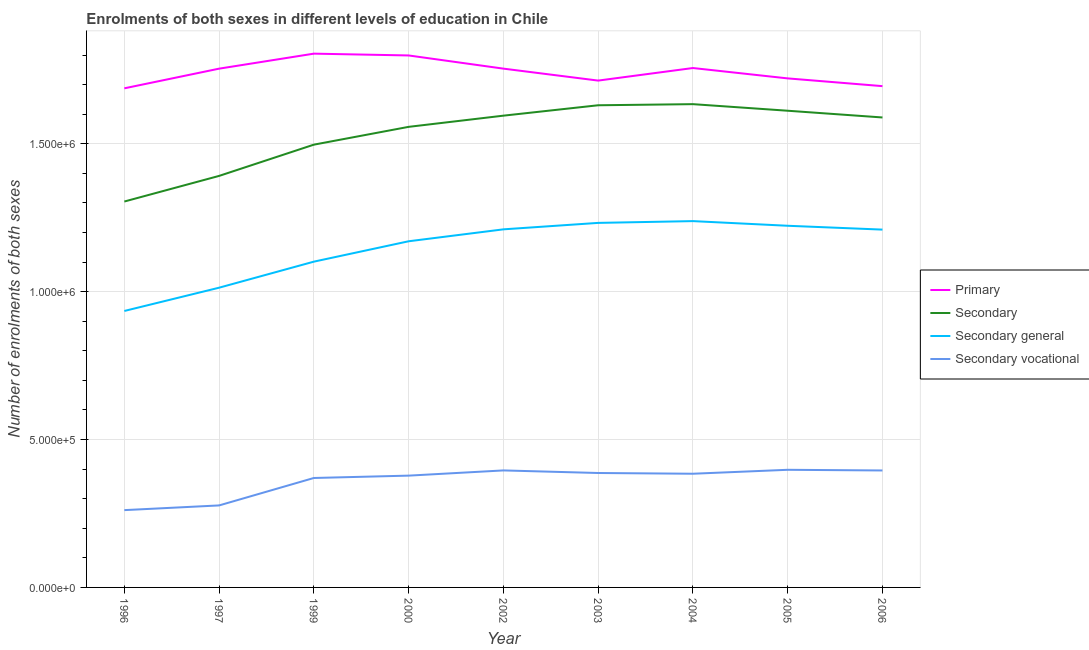Does the line corresponding to number of enrolments in secondary general education intersect with the line corresponding to number of enrolments in primary education?
Your answer should be compact. No. Is the number of lines equal to the number of legend labels?
Your answer should be very brief. Yes. What is the number of enrolments in secondary vocational education in 2004?
Your answer should be very brief. 3.84e+05. Across all years, what is the maximum number of enrolments in primary education?
Ensure brevity in your answer.  1.80e+06. Across all years, what is the minimum number of enrolments in secondary general education?
Offer a terse response. 9.35e+05. What is the total number of enrolments in secondary vocational education in the graph?
Give a very brief answer. 3.25e+06. What is the difference between the number of enrolments in secondary general education in 2002 and that in 2004?
Give a very brief answer. -2.78e+04. What is the difference between the number of enrolments in primary education in 2002 and the number of enrolments in secondary general education in 2000?
Your answer should be very brief. 5.84e+05. What is the average number of enrolments in secondary vocational education per year?
Provide a succinct answer. 3.61e+05. In the year 1996, what is the difference between the number of enrolments in secondary vocational education and number of enrolments in secondary general education?
Offer a very short reply. -6.73e+05. In how many years, is the number of enrolments in secondary general education greater than 500000?
Give a very brief answer. 9. What is the ratio of the number of enrolments in secondary education in 2000 to that in 2004?
Your answer should be very brief. 0.95. Is the number of enrolments in secondary vocational education in 1997 less than that in 2003?
Provide a short and direct response. Yes. What is the difference between the highest and the second highest number of enrolments in secondary vocational education?
Give a very brief answer. 2116. What is the difference between the highest and the lowest number of enrolments in secondary general education?
Your response must be concise. 3.04e+05. Is the sum of the number of enrolments in primary education in 1997 and 2005 greater than the maximum number of enrolments in secondary general education across all years?
Your response must be concise. Yes. Is it the case that in every year, the sum of the number of enrolments in secondary education and number of enrolments in primary education is greater than the sum of number of enrolments in secondary general education and number of enrolments in secondary vocational education?
Your answer should be compact. No. Does the number of enrolments in primary education monotonically increase over the years?
Keep it short and to the point. No. How many years are there in the graph?
Your response must be concise. 9. What is the difference between two consecutive major ticks on the Y-axis?
Give a very brief answer. 5.00e+05. Are the values on the major ticks of Y-axis written in scientific E-notation?
Make the answer very short. Yes. How many legend labels are there?
Provide a short and direct response. 4. How are the legend labels stacked?
Keep it short and to the point. Vertical. What is the title of the graph?
Give a very brief answer. Enrolments of both sexes in different levels of education in Chile. Does "Japan" appear as one of the legend labels in the graph?
Give a very brief answer. No. What is the label or title of the X-axis?
Ensure brevity in your answer.  Year. What is the label or title of the Y-axis?
Provide a short and direct response. Number of enrolments of both sexes. What is the Number of enrolments of both sexes of Primary in 1996?
Provide a short and direct response. 1.69e+06. What is the Number of enrolments of both sexes in Secondary in 1996?
Your answer should be compact. 1.30e+06. What is the Number of enrolments of both sexes in Secondary general in 1996?
Provide a succinct answer. 9.35e+05. What is the Number of enrolments of both sexes of Secondary vocational in 1996?
Your answer should be compact. 2.61e+05. What is the Number of enrolments of both sexes of Primary in 1997?
Provide a short and direct response. 1.75e+06. What is the Number of enrolments of both sexes of Secondary in 1997?
Your response must be concise. 1.39e+06. What is the Number of enrolments of both sexes in Secondary general in 1997?
Your answer should be very brief. 1.01e+06. What is the Number of enrolments of both sexes in Secondary vocational in 1997?
Keep it short and to the point. 2.77e+05. What is the Number of enrolments of both sexes in Primary in 1999?
Ensure brevity in your answer.  1.80e+06. What is the Number of enrolments of both sexes of Secondary in 1999?
Ensure brevity in your answer.  1.50e+06. What is the Number of enrolments of both sexes in Secondary general in 1999?
Make the answer very short. 1.10e+06. What is the Number of enrolments of both sexes of Secondary vocational in 1999?
Keep it short and to the point. 3.70e+05. What is the Number of enrolments of both sexes in Primary in 2000?
Ensure brevity in your answer.  1.80e+06. What is the Number of enrolments of both sexes of Secondary in 2000?
Give a very brief answer. 1.56e+06. What is the Number of enrolments of both sexes in Secondary general in 2000?
Provide a short and direct response. 1.17e+06. What is the Number of enrolments of both sexes of Secondary vocational in 2000?
Give a very brief answer. 3.78e+05. What is the Number of enrolments of both sexes in Primary in 2002?
Ensure brevity in your answer.  1.75e+06. What is the Number of enrolments of both sexes in Secondary in 2002?
Give a very brief answer. 1.59e+06. What is the Number of enrolments of both sexes of Secondary general in 2002?
Provide a short and direct response. 1.21e+06. What is the Number of enrolments of both sexes of Secondary vocational in 2002?
Make the answer very short. 3.96e+05. What is the Number of enrolments of both sexes of Primary in 2003?
Your answer should be compact. 1.71e+06. What is the Number of enrolments of both sexes of Secondary in 2003?
Ensure brevity in your answer.  1.63e+06. What is the Number of enrolments of both sexes in Secondary general in 2003?
Make the answer very short. 1.23e+06. What is the Number of enrolments of both sexes in Secondary vocational in 2003?
Provide a succinct answer. 3.87e+05. What is the Number of enrolments of both sexes in Primary in 2004?
Offer a very short reply. 1.76e+06. What is the Number of enrolments of both sexes in Secondary in 2004?
Offer a very short reply. 1.63e+06. What is the Number of enrolments of both sexes in Secondary general in 2004?
Ensure brevity in your answer.  1.24e+06. What is the Number of enrolments of both sexes of Secondary vocational in 2004?
Offer a very short reply. 3.84e+05. What is the Number of enrolments of both sexes in Primary in 2005?
Provide a short and direct response. 1.72e+06. What is the Number of enrolments of both sexes in Secondary in 2005?
Give a very brief answer. 1.61e+06. What is the Number of enrolments of both sexes of Secondary general in 2005?
Your response must be concise. 1.22e+06. What is the Number of enrolments of both sexes of Secondary vocational in 2005?
Your answer should be compact. 3.98e+05. What is the Number of enrolments of both sexes in Primary in 2006?
Offer a terse response. 1.69e+06. What is the Number of enrolments of both sexes in Secondary in 2006?
Offer a terse response. 1.59e+06. What is the Number of enrolments of both sexes of Secondary general in 2006?
Make the answer very short. 1.21e+06. What is the Number of enrolments of both sexes of Secondary vocational in 2006?
Offer a very short reply. 3.95e+05. Across all years, what is the maximum Number of enrolments of both sexes in Primary?
Give a very brief answer. 1.80e+06. Across all years, what is the maximum Number of enrolments of both sexes in Secondary?
Your answer should be compact. 1.63e+06. Across all years, what is the maximum Number of enrolments of both sexes of Secondary general?
Provide a succinct answer. 1.24e+06. Across all years, what is the maximum Number of enrolments of both sexes in Secondary vocational?
Ensure brevity in your answer.  3.98e+05. Across all years, what is the minimum Number of enrolments of both sexes of Primary?
Your answer should be very brief. 1.69e+06. Across all years, what is the minimum Number of enrolments of both sexes of Secondary?
Keep it short and to the point. 1.30e+06. Across all years, what is the minimum Number of enrolments of both sexes of Secondary general?
Ensure brevity in your answer.  9.35e+05. Across all years, what is the minimum Number of enrolments of both sexes of Secondary vocational?
Your response must be concise. 2.61e+05. What is the total Number of enrolments of both sexes of Primary in the graph?
Ensure brevity in your answer.  1.57e+07. What is the total Number of enrolments of both sexes of Secondary in the graph?
Your answer should be compact. 1.38e+07. What is the total Number of enrolments of both sexes of Secondary general in the graph?
Make the answer very short. 1.03e+07. What is the total Number of enrolments of both sexes in Secondary vocational in the graph?
Offer a terse response. 3.25e+06. What is the difference between the Number of enrolments of both sexes in Primary in 1996 and that in 1997?
Offer a terse response. -6.65e+04. What is the difference between the Number of enrolments of both sexes in Secondary in 1996 and that in 1997?
Give a very brief answer. -8.66e+04. What is the difference between the Number of enrolments of both sexes in Secondary general in 1996 and that in 1997?
Your answer should be compact. -7.87e+04. What is the difference between the Number of enrolments of both sexes of Secondary vocational in 1996 and that in 1997?
Ensure brevity in your answer.  -1.59e+04. What is the difference between the Number of enrolments of both sexes of Primary in 1996 and that in 1999?
Make the answer very short. -1.17e+05. What is the difference between the Number of enrolments of both sexes of Secondary in 1996 and that in 1999?
Your answer should be compact. -1.92e+05. What is the difference between the Number of enrolments of both sexes in Secondary general in 1996 and that in 1999?
Your answer should be compact. -1.67e+05. What is the difference between the Number of enrolments of both sexes of Secondary vocational in 1996 and that in 1999?
Provide a succinct answer. -1.09e+05. What is the difference between the Number of enrolments of both sexes of Primary in 1996 and that in 2000?
Ensure brevity in your answer.  -1.11e+05. What is the difference between the Number of enrolments of both sexes of Secondary in 1996 and that in 2000?
Offer a terse response. -2.52e+05. What is the difference between the Number of enrolments of both sexes in Secondary general in 1996 and that in 2000?
Offer a terse response. -2.36e+05. What is the difference between the Number of enrolments of both sexes of Secondary vocational in 1996 and that in 2000?
Provide a short and direct response. -1.17e+05. What is the difference between the Number of enrolments of both sexes of Primary in 1996 and that in 2002?
Provide a short and direct response. -6.66e+04. What is the difference between the Number of enrolments of both sexes in Secondary in 1996 and that in 2002?
Your answer should be compact. -2.90e+05. What is the difference between the Number of enrolments of both sexes in Secondary general in 1996 and that in 2002?
Ensure brevity in your answer.  -2.76e+05. What is the difference between the Number of enrolments of both sexes of Secondary vocational in 1996 and that in 2002?
Give a very brief answer. -1.34e+05. What is the difference between the Number of enrolments of both sexes of Primary in 1996 and that in 2003?
Your response must be concise. -2.62e+04. What is the difference between the Number of enrolments of both sexes of Secondary in 1996 and that in 2003?
Your answer should be very brief. -3.25e+05. What is the difference between the Number of enrolments of both sexes of Secondary general in 1996 and that in 2003?
Your response must be concise. -2.98e+05. What is the difference between the Number of enrolments of both sexes in Secondary vocational in 1996 and that in 2003?
Offer a very short reply. -1.25e+05. What is the difference between the Number of enrolments of both sexes of Primary in 1996 and that in 2004?
Offer a very short reply. -6.86e+04. What is the difference between the Number of enrolments of both sexes of Secondary in 1996 and that in 2004?
Keep it short and to the point. -3.29e+05. What is the difference between the Number of enrolments of both sexes of Secondary general in 1996 and that in 2004?
Your response must be concise. -3.04e+05. What is the difference between the Number of enrolments of both sexes in Secondary vocational in 1996 and that in 2004?
Provide a short and direct response. -1.23e+05. What is the difference between the Number of enrolments of both sexes of Primary in 1996 and that in 2005?
Your response must be concise. -3.36e+04. What is the difference between the Number of enrolments of both sexes of Secondary in 1996 and that in 2005?
Provide a short and direct response. -3.07e+05. What is the difference between the Number of enrolments of both sexes of Secondary general in 1996 and that in 2005?
Provide a short and direct response. -2.88e+05. What is the difference between the Number of enrolments of both sexes in Secondary vocational in 1996 and that in 2005?
Your response must be concise. -1.36e+05. What is the difference between the Number of enrolments of both sexes of Primary in 1996 and that in 2006?
Ensure brevity in your answer.  -7379. What is the difference between the Number of enrolments of both sexes of Secondary in 1996 and that in 2006?
Keep it short and to the point. -2.84e+05. What is the difference between the Number of enrolments of both sexes in Secondary general in 1996 and that in 2006?
Offer a very short reply. -2.75e+05. What is the difference between the Number of enrolments of both sexes of Secondary vocational in 1996 and that in 2006?
Offer a very short reply. -1.34e+05. What is the difference between the Number of enrolments of both sexes of Primary in 1997 and that in 1999?
Your response must be concise. -5.07e+04. What is the difference between the Number of enrolments of both sexes in Secondary in 1997 and that in 1999?
Give a very brief answer. -1.06e+05. What is the difference between the Number of enrolments of both sexes of Secondary general in 1997 and that in 1999?
Give a very brief answer. -8.81e+04. What is the difference between the Number of enrolments of both sexes of Secondary vocational in 1997 and that in 1999?
Your answer should be very brief. -9.28e+04. What is the difference between the Number of enrolments of both sexes in Primary in 1997 and that in 2000?
Your answer should be very brief. -4.46e+04. What is the difference between the Number of enrolments of both sexes of Secondary in 1997 and that in 2000?
Your response must be concise. -1.66e+05. What is the difference between the Number of enrolments of both sexes in Secondary general in 1997 and that in 2000?
Offer a terse response. -1.57e+05. What is the difference between the Number of enrolments of both sexes in Secondary vocational in 1997 and that in 2000?
Your answer should be very brief. -1.01e+05. What is the difference between the Number of enrolments of both sexes of Primary in 1997 and that in 2002?
Make the answer very short. -85. What is the difference between the Number of enrolments of both sexes in Secondary in 1997 and that in 2002?
Give a very brief answer. -2.04e+05. What is the difference between the Number of enrolments of both sexes of Secondary general in 1997 and that in 2002?
Your answer should be very brief. -1.97e+05. What is the difference between the Number of enrolments of both sexes in Secondary vocational in 1997 and that in 2002?
Make the answer very short. -1.18e+05. What is the difference between the Number of enrolments of both sexes of Primary in 1997 and that in 2003?
Give a very brief answer. 4.03e+04. What is the difference between the Number of enrolments of both sexes in Secondary in 1997 and that in 2003?
Give a very brief answer. -2.39e+05. What is the difference between the Number of enrolments of both sexes in Secondary general in 1997 and that in 2003?
Your response must be concise. -2.19e+05. What is the difference between the Number of enrolments of both sexes of Secondary vocational in 1997 and that in 2003?
Give a very brief answer. -1.10e+05. What is the difference between the Number of enrolments of both sexes in Primary in 1997 and that in 2004?
Provide a short and direct response. -2130. What is the difference between the Number of enrolments of both sexes in Secondary in 1997 and that in 2004?
Provide a short and direct response. -2.43e+05. What is the difference between the Number of enrolments of both sexes in Secondary general in 1997 and that in 2004?
Keep it short and to the point. -2.25e+05. What is the difference between the Number of enrolments of both sexes of Secondary vocational in 1997 and that in 2004?
Keep it short and to the point. -1.07e+05. What is the difference between the Number of enrolments of both sexes in Primary in 1997 and that in 2005?
Keep it short and to the point. 3.29e+04. What is the difference between the Number of enrolments of both sexes in Secondary in 1997 and that in 2005?
Ensure brevity in your answer.  -2.20e+05. What is the difference between the Number of enrolments of both sexes in Secondary general in 1997 and that in 2005?
Provide a short and direct response. -2.09e+05. What is the difference between the Number of enrolments of both sexes in Secondary vocational in 1997 and that in 2005?
Provide a short and direct response. -1.20e+05. What is the difference between the Number of enrolments of both sexes in Primary in 1997 and that in 2006?
Give a very brief answer. 5.91e+04. What is the difference between the Number of enrolments of both sexes of Secondary in 1997 and that in 2006?
Offer a very short reply. -1.98e+05. What is the difference between the Number of enrolments of both sexes in Secondary general in 1997 and that in 2006?
Provide a succinct answer. -1.96e+05. What is the difference between the Number of enrolments of both sexes of Secondary vocational in 1997 and that in 2006?
Your response must be concise. -1.18e+05. What is the difference between the Number of enrolments of both sexes of Primary in 1999 and that in 2000?
Ensure brevity in your answer.  6097. What is the difference between the Number of enrolments of both sexes of Secondary in 1999 and that in 2000?
Provide a short and direct response. -6.02e+04. What is the difference between the Number of enrolments of both sexes in Secondary general in 1999 and that in 2000?
Make the answer very short. -6.89e+04. What is the difference between the Number of enrolments of both sexes in Secondary vocational in 1999 and that in 2000?
Your answer should be very brief. -7942. What is the difference between the Number of enrolments of both sexes of Primary in 1999 and that in 2002?
Offer a terse response. 5.07e+04. What is the difference between the Number of enrolments of both sexes in Secondary in 1999 and that in 2002?
Give a very brief answer. -9.80e+04. What is the difference between the Number of enrolments of both sexes in Secondary general in 1999 and that in 2002?
Your answer should be very brief. -1.09e+05. What is the difference between the Number of enrolments of both sexes in Secondary vocational in 1999 and that in 2002?
Your answer should be compact. -2.55e+04. What is the difference between the Number of enrolments of both sexes in Primary in 1999 and that in 2003?
Your response must be concise. 9.11e+04. What is the difference between the Number of enrolments of both sexes in Secondary in 1999 and that in 2003?
Offer a terse response. -1.33e+05. What is the difference between the Number of enrolments of both sexes in Secondary general in 1999 and that in 2003?
Provide a short and direct response. -1.31e+05. What is the difference between the Number of enrolments of both sexes in Secondary vocational in 1999 and that in 2003?
Provide a short and direct response. -1.68e+04. What is the difference between the Number of enrolments of both sexes of Primary in 1999 and that in 2004?
Your answer should be compact. 4.86e+04. What is the difference between the Number of enrolments of both sexes of Secondary in 1999 and that in 2004?
Your answer should be very brief. -1.37e+05. What is the difference between the Number of enrolments of both sexes of Secondary general in 1999 and that in 2004?
Keep it short and to the point. -1.37e+05. What is the difference between the Number of enrolments of both sexes in Secondary vocational in 1999 and that in 2004?
Your answer should be very brief. -1.43e+04. What is the difference between the Number of enrolments of both sexes of Primary in 1999 and that in 2005?
Provide a short and direct response. 8.37e+04. What is the difference between the Number of enrolments of both sexes of Secondary in 1999 and that in 2005?
Offer a terse response. -1.15e+05. What is the difference between the Number of enrolments of both sexes in Secondary general in 1999 and that in 2005?
Your answer should be very brief. -1.21e+05. What is the difference between the Number of enrolments of both sexes in Secondary vocational in 1999 and that in 2005?
Provide a short and direct response. -2.77e+04. What is the difference between the Number of enrolments of both sexes of Primary in 1999 and that in 2006?
Your answer should be very brief. 1.10e+05. What is the difference between the Number of enrolments of both sexes of Secondary in 1999 and that in 2006?
Offer a very short reply. -9.19e+04. What is the difference between the Number of enrolments of both sexes in Secondary general in 1999 and that in 2006?
Make the answer very short. -1.08e+05. What is the difference between the Number of enrolments of both sexes in Secondary vocational in 1999 and that in 2006?
Your response must be concise. -2.54e+04. What is the difference between the Number of enrolments of both sexes in Primary in 2000 and that in 2002?
Provide a short and direct response. 4.46e+04. What is the difference between the Number of enrolments of both sexes of Secondary in 2000 and that in 2002?
Make the answer very short. -3.78e+04. What is the difference between the Number of enrolments of both sexes of Secondary general in 2000 and that in 2002?
Give a very brief answer. -4.03e+04. What is the difference between the Number of enrolments of both sexes of Secondary vocational in 2000 and that in 2002?
Provide a succinct answer. -1.76e+04. What is the difference between the Number of enrolments of both sexes in Primary in 2000 and that in 2003?
Give a very brief answer. 8.50e+04. What is the difference between the Number of enrolments of both sexes of Secondary in 2000 and that in 2003?
Offer a terse response. -7.30e+04. What is the difference between the Number of enrolments of both sexes in Secondary general in 2000 and that in 2003?
Offer a terse response. -6.21e+04. What is the difference between the Number of enrolments of both sexes in Secondary vocational in 2000 and that in 2003?
Ensure brevity in your answer.  -8874. What is the difference between the Number of enrolments of both sexes in Primary in 2000 and that in 2004?
Make the answer very short. 4.25e+04. What is the difference between the Number of enrolments of both sexes of Secondary in 2000 and that in 2004?
Provide a short and direct response. -7.67e+04. What is the difference between the Number of enrolments of both sexes of Secondary general in 2000 and that in 2004?
Ensure brevity in your answer.  -6.82e+04. What is the difference between the Number of enrolments of both sexes of Secondary vocational in 2000 and that in 2004?
Keep it short and to the point. -6397. What is the difference between the Number of enrolments of both sexes of Primary in 2000 and that in 2005?
Your response must be concise. 7.76e+04. What is the difference between the Number of enrolments of both sexes of Secondary in 2000 and that in 2005?
Offer a terse response. -5.45e+04. What is the difference between the Number of enrolments of both sexes of Secondary general in 2000 and that in 2005?
Your answer should be very brief. -5.24e+04. What is the difference between the Number of enrolments of both sexes of Secondary vocational in 2000 and that in 2005?
Your response must be concise. -1.97e+04. What is the difference between the Number of enrolments of both sexes of Primary in 2000 and that in 2006?
Give a very brief answer. 1.04e+05. What is the difference between the Number of enrolments of both sexes in Secondary in 2000 and that in 2006?
Provide a short and direct response. -3.17e+04. What is the difference between the Number of enrolments of both sexes of Secondary general in 2000 and that in 2006?
Provide a succinct answer. -3.94e+04. What is the difference between the Number of enrolments of both sexes of Secondary vocational in 2000 and that in 2006?
Offer a very short reply. -1.75e+04. What is the difference between the Number of enrolments of both sexes of Primary in 2002 and that in 2003?
Your answer should be very brief. 4.04e+04. What is the difference between the Number of enrolments of both sexes in Secondary in 2002 and that in 2003?
Ensure brevity in your answer.  -3.51e+04. What is the difference between the Number of enrolments of both sexes in Secondary general in 2002 and that in 2003?
Ensure brevity in your answer.  -2.18e+04. What is the difference between the Number of enrolments of both sexes in Secondary vocational in 2002 and that in 2003?
Make the answer very short. 8725. What is the difference between the Number of enrolments of both sexes in Primary in 2002 and that in 2004?
Offer a terse response. -2045. What is the difference between the Number of enrolments of both sexes of Secondary in 2002 and that in 2004?
Provide a short and direct response. -3.89e+04. What is the difference between the Number of enrolments of both sexes in Secondary general in 2002 and that in 2004?
Give a very brief answer. -2.78e+04. What is the difference between the Number of enrolments of both sexes in Secondary vocational in 2002 and that in 2004?
Offer a terse response. 1.12e+04. What is the difference between the Number of enrolments of both sexes in Primary in 2002 and that in 2005?
Ensure brevity in your answer.  3.30e+04. What is the difference between the Number of enrolments of both sexes in Secondary in 2002 and that in 2005?
Your answer should be compact. -1.67e+04. What is the difference between the Number of enrolments of both sexes of Secondary general in 2002 and that in 2005?
Offer a terse response. -1.21e+04. What is the difference between the Number of enrolments of both sexes in Secondary vocational in 2002 and that in 2005?
Offer a terse response. -2116. What is the difference between the Number of enrolments of both sexes of Primary in 2002 and that in 2006?
Provide a succinct answer. 5.92e+04. What is the difference between the Number of enrolments of both sexes of Secondary in 2002 and that in 2006?
Make the answer very short. 6130. What is the difference between the Number of enrolments of both sexes of Secondary general in 2002 and that in 2006?
Your answer should be compact. 890. What is the difference between the Number of enrolments of both sexes in Secondary vocational in 2002 and that in 2006?
Ensure brevity in your answer.  137. What is the difference between the Number of enrolments of both sexes in Primary in 2003 and that in 2004?
Your answer should be very brief. -4.25e+04. What is the difference between the Number of enrolments of both sexes of Secondary in 2003 and that in 2004?
Your answer should be compact. -3769. What is the difference between the Number of enrolments of both sexes of Secondary general in 2003 and that in 2004?
Make the answer very short. -6022. What is the difference between the Number of enrolments of both sexes of Secondary vocational in 2003 and that in 2004?
Offer a very short reply. 2477. What is the difference between the Number of enrolments of both sexes in Primary in 2003 and that in 2005?
Provide a short and direct response. -7413. What is the difference between the Number of enrolments of both sexes of Secondary in 2003 and that in 2005?
Provide a short and direct response. 1.85e+04. What is the difference between the Number of enrolments of both sexes of Secondary general in 2003 and that in 2005?
Make the answer very short. 9716. What is the difference between the Number of enrolments of both sexes of Secondary vocational in 2003 and that in 2005?
Keep it short and to the point. -1.08e+04. What is the difference between the Number of enrolments of both sexes of Primary in 2003 and that in 2006?
Offer a very short reply. 1.88e+04. What is the difference between the Number of enrolments of both sexes in Secondary in 2003 and that in 2006?
Provide a short and direct response. 4.13e+04. What is the difference between the Number of enrolments of both sexes of Secondary general in 2003 and that in 2006?
Make the answer very short. 2.27e+04. What is the difference between the Number of enrolments of both sexes in Secondary vocational in 2003 and that in 2006?
Offer a very short reply. -8588. What is the difference between the Number of enrolments of both sexes of Primary in 2004 and that in 2005?
Give a very brief answer. 3.50e+04. What is the difference between the Number of enrolments of both sexes in Secondary in 2004 and that in 2005?
Ensure brevity in your answer.  2.22e+04. What is the difference between the Number of enrolments of both sexes of Secondary general in 2004 and that in 2005?
Your answer should be compact. 1.57e+04. What is the difference between the Number of enrolments of both sexes in Secondary vocational in 2004 and that in 2005?
Ensure brevity in your answer.  -1.33e+04. What is the difference between the Number of enrolments of both sexes in Primary in 2004 and that in 2006?
Provide a succinct answer. 6.12e+04. What is the difference between the Number of enrolments of both sexes of Secondary in 2004 and that in 2006?
Your answer should be very brief. 4.50e+04. What is the difference between the Number of enrolments of both sexes in Secondary general in 2004 and that in 2006?
Your answer should be very brief. 2.87e+04. What is the difference between the Number of enrolments of both sexes of Secondary vocational in 2004 and that in 2006?
Offer a very short reply. -1.11e+04. What is the difference between the Number of enrolments of both sexes in Primary in 2005 and that in 2006?
Offer a terse response. 2.62e+04. What is the difference between the Number of enrolments of both sexes of Secondary in 2005 and that in 2006?
Your response must be concise. 2.28e+04. What is the difference between the Number of enrolments of both sexes of Secondary general in 2005 and that in 2006?
Make the answer very short. 1.30e+04. What is the difference between the Number of enrolments of both sexes of Secondary vocational in 2005 and that in 2006?
Make the answer very short. 2253. What is the difference between the Number of enrolments of both sexes of Primary in 1996 and the Number of enrolments of both sexes of Secondary in 1997?
Provide a short and direct response. 2.96e+05. What is the difference between the Number of enrolments of both sexes of Primary in 1996 and the Number of enrolments of both sexes of Secondary general in 1997?
Your response must be concise. 6.74e+05. What is the difference between the Number of enrolments of both sexes of Primary in 1996 and the Number of enrolments of both sexes of Secondary vocational in 1997?
Provide a short and direct response. 1.41e+06. What is the difference between the Number of enrolments of both sexes in Secondary in 1996 and the Number of enrolments of both sexes in Secondary general in 1997?
Make the answer very short. 2.91e+05. What is the difference between the Number of enrolments of both sexes of Secondary in 1996 and the Number of enrolments of both sexes of Secondary vocational in 1997?
Your answer should be compact. 1.03e+06. What is the difference between the Number of enrolments of both sexes of Secondary general in 1996 and the Number of enrolments of both sexes of Secondary vocational in 1997?
Your response must be concise. 6.57e+05. What is the difference between the Number of enrolments of both sexes in Primary in 1996 and the Number of enrolments of both sexes in Secondary in 1999?
Keep it short and to the point. 1.90e+05. What is the difference between the Number of enrolments of both sexes of Primary in 1996 and the Number of enrolments of both sexes of Secondary general in 1999?
Keep it short and to the point. 5.86e+05. What is the difference between the Number of enrolments of both sexes of Primary in 1996 and the Number of enrolments of both sexes of Secondary vocational in 1999?
Make the answer very short. 1.32e+06. What is the difference between the Number of enrolments of both sexes in Secondary in 1996 and the Number of enrolments of both sexes in Secondary general in 1999?
Offer a terse response. 2.03e+05. What is the difference between the Number of enrolments of both sexes in Secondary in 1996 and the Number of enrolments of both sexes in Secondary vocational in 1999?
Keep it short and to the point. 9.35e+05. What is the difference between the Number of enrolments of both sexes in Secondary general in 1996 and the Number of enrolments of both sexes in Secondary vocational in 1999?
Your answer should be compact. 5.65e+05. What is the difference between the Number of enrolments of both sexes in Primary in 1996 and the Number of enrolments of both sexes in Secondary in 2000?
Provide a short and direct response. 1.30e+05. What is the difference between the Number of enrolments of both sexes in Primary in 1996 and the Number of enrolments of both sexes in Secondary general in 2000?
Make the answer very short. 5.17e+05. What is the difference between the Number of enrolments of both sexes in Primary in 1996 and the Number of enrolments of both sexes in Secondary vocational in 2000?
Your answer should be very brief. 1.31e+06. What is the difference between the Number of enrolments of both sexes of Secondary in 1996 and the Number of enrolments of both sexes of Secondary general in 2000?
Offer a very short reply. 1.34e+05. What is the difference between the Number of enrolments of both sexes in Secondary in 1996 and the Number of enrolments of both sexes in Secondary vocational in 2000?
Make the answer very short. 9.27e+05. What is the difference between the Number of enrolments of both sexes of Secondary general in 1996 and the Number of enrolments of both sexes of Secondary vocational in 2000?
Offer a very short reply. 5.57e+05. What is the difference between the Number of enrolments of both sexes in Primary in 1996 and the Number of enrolments of both sexes in Secondary in 2002?
Your answer should be compact. 9.24e+04. What is the difference between the Number of enrolments of both sexes of Primary in 1996 and the Number of enrolments of both sexes of Secondary general in 2002?
Your answer should be compact. 4.77e+05. What is the difference between the Number of enrolments of both sexes of Primary in 1996 and the Number of enrolments of both sexes of Secondary vocational in 2002?
Provide a short and direct response. 1.29e+06. What is the difference between the Number of enrolments of both sexes of Secondary in 1996 and the Number of enrolments of both sexes of Secondary general in 2002?
Keep it short and to the point. 9.41e+04. What is the difference between the Number of enrolments of both sexes of Secondary in 1996 and the Number of enrolments of both sexes of Secondary vocational in 2002?
Ensure brevity in your answer.  9.09e+05. What is the difference between the Number of enrolments of both sexes in Secondary general in 1996 and the Number of enrolments of both sexes in Secondary vocational in 2002?
Provide a short and direct response. 5.39e+05. What is the difference between the Number of enrolments of both sexes of Primary in 1996 and the Number of enrolments of both sexes of Secondary in 2003?
Offer a terse response. 5.73e+04. What is the difference between the Number of enrolments of both sexes in Primary in 1996 and the Number of enrolments of both sexes in Secondary general in 2003?
Give a very brief answer. 4.55e+05. What is the difference between the Number of enrolments of both sexes in Primary in 1996 and the Number of enrolments of both sexes in Secondary vocational in 2003?
Provide a short and direct response. 1.30e+06. What is the difference between the Number of enrolments of both sexes of Secondary in 1996 and the Number of enrolments of both sexes of Secondary general in 2003?
Ensure brevity in your answer.  7.23e+04. What is the difference between the Number of enrolments of both sexes of Secondary in 1996 and the Number of enrolments of both sexes of Secondary vocational in 2003?
Offer a very short reply. 9.18e+05. What is the difference between the Number of enrolments of both sexes in Secondary general in 1996 and the Number of enrolments of both sexes in Secondary vocational in 2003?
Offer a very short reply. 5.48e+05. What is the difference between the Number of enrolments of both sexes of Primary in 1996 and the Number of enrolments of both sexes of Secondary in 2004?
Your response must be concise. 5.35e+04. What is the difference between the Number of enrolments of both sexes in Primary in 1996 and the Number of enrolments of both sexes in Secondary general in 2004?
Provide a short and direct response. 4.49e+05. What is the difference between the Number of enrolments of both sexes of Primary in 1996 and the Number of enrolments of both sexes of Secondary vocational in 2004?
Offer a very short reply. 1.30e+06. What is the difference between the Number of enrolments of both sexes in Secondary in 1996 and the Number of enrolments of both sexes in Secondary general in 2004?
Your response must be concise. 6.62e+04. What is the difference between the Number of enrolments of both sexes of Secondary in 1996 and the Number of enrolments of both sexes of Secondary vocational in 2004?
Offer a terse response. 9.20e+05. What is the difference between the Number of enrolments of both sexes in Secondary general in 1996 and the Number of enrolments of both sexes in Secondary vocational in 2004?
Offer a very short reply. 5.50e+05. What is the difference between the Number of enrolments of both sexes in Primary in 1996 and the Number of enrolments of both sexes in Secondary in 2005?
Your answer should be very brief. 7.58e+04. What is the difference between the Number of enrolments of both sexes in Primary in 1996 and the Number of enrolments of both sexes in Secondary general in 2005?
Make the answer very short. 4.65e+05. What is the difference between the Number of enrolments of both sexes in Primary in 1996 and the Number of enrolments of both sexes in Secondary vocational in 2005?
Give a very brief answer. 1.29e+06. What is the difference between the Number of enrolments of both sexes in Secondary in 1996 and the Number of enrolments of both sexes in Secondary general in 2005?
Provide a succinct answer. 8.20e+04. What is the difference between the Number of enrolments of both sexes in Secondary in 1996 and the Number of enrolments of both sexes in Secondary vocational in 2005?
Make the answer very short. 9.07e+05. What is the difference between the Number of enrolments of both sexes of Secondary general in 1996 and the Number of enrolments of both sexes of Secondary vocational in 2005?
Make the answer very short. 5.37e+05. What is the difference between the Number of enrolments of both sexes in Primary in 1996 and the Number of enrolments of both sexes in Secondary in 2006?
Keep it short and to the point. 9.86e+04. What is the difference between the Number of enrolments of both sexes in Primary in 1996 and the Number of enrolments of both sexes in Secondary general in 2006?
Your answer should be compact. 4.78e+05. What is the difference between the Number of enrolments of both sexes in Primary in 1996 and the Number of enrolments of both sexes in Secondary vocational in 2006?
Keep it short and to the point. 1.29e+06. What is the difference between the Number of enrolments of both sexes in Secondary in 1996 and the Number of enrolments of both sexes in Secondary general in 2006?
Offer a terse response. 9.50e+04. What is the difference between the Number of enrolments of both sexes in Secondary in 1996 and the Number of enrolments of both sexes in Secondary vocational in 2006?
Give a very brief answer. 9.09e+05. What is the difference between the Number of enrolments of both sexes of Secondary general in 1996 and the Number of enrolments of both sexes of Secondary vocational in 2006?
Your response must be concise. 5.39e+05. What is the difference between the Number of enrolments of both sexes in Primary in 1997 and the Number of enrolments of both sexes in Secondary in 1999?
Provide a succinct answer. 2.57e+05. What is the difference between the Number of enrolments of both sexes in Primary in 1997 and the Number of enrolments of both sexes in Secondary general in 1999?
Offer a terse response. 6.52e+05. What is the difference between the Number of enrolments of both sexes in Primary in 1997 and the Number of enrolments of both sexes in Secondary vocational in 1999?
Keep it short and to the point. 1.38e+06. What is the difference between the Number of enrolments of both sexes of Secondary in 1997 and the Number of enrolments of both sexes of Secondary general in 1999?
Give a very brief answer. 2.90e+05. What is the difference between the Number of enrolments of both sexes in Secondary in 1997 and the Number of enrolments of both sexes in Secondary vocational in 1999?
Keep it short and to the point. 1.02e+06. What is the difference between the Number of enrolments of both sexes in Secondary general in 1997 and the Number of enrolments of both sexes in Secondary vocational in 1999?
Your answer should be compact. 6.43e+05. What is the difference between the Number of enrolments of both sexes of Primary in 1997 and the Number of enrolments of both sexes of Secondary in 2000?
Keep it short and to the point. 1.97e+05. What is the difference between the Number of enrolments of both sexes of Primary in 1997 and the Number of enrolments of both sexes of Secondary general in 2000?
Make the answer very short. 5.84e+05. What is the difference between the Number of enrolments of both sexes in Primary in 1997 and the Number of enrolments of both sexes in Secondary vocational in 2000?
Keep it short and to the point. 1.38e+06. What is the difference between the Number of enrolments of both sexes of Secondary in 1997 and the Number of enrolments of both sexes of Secondary general in 2000?
Your answer should be compact. 2.21e+05. What is the difference between the Number of enrolments of both sexes of Secondary in 1997 and the Number of enrolments of both sexes of Secondary vocational in 2000?
Provide a succinct answer. 1.01e+06. What is the difference between the Number of enrolments of both sexes in Secondary general in 1997 and the Number of enrolments of both sexes in Secondary vocational in 2000?
Ensure brevity in your answer.  6.35e+05. What is the difference between the Number of enrolments of both sexes in Primary in 1997 and the Number of enrolments of both sexes in Secondary in 2002?
Provide a succinct answer. 1.59e+05. What is the difference between the Number of enrolments of both sexes in Primary in 1997 and the Number of enrolments of both sexes in Secondary general in 2002?
Your response must be concise. 5.43e+05. What is the difference between the Number of enrolments of both sexes in Primary in 1997 and the Number of enrolments of both sexes in Secondary vocational in 2002?
Give a very brief answer. 1.36e+06. What is the difference between the Number of enrolments of both sexes of Secondary in 1997 and the Number of enrolments of both sexes of Secondary general in 2002?
Your response must be concise. 1.81e+05. What is the difference between the Number of enrolments of both sexes in Secondary in 1997 and the Number of enrolments of both sexes in Secondary vocational in 2002?
Your answer should be compact. 9.96e+05. What is the difference between the Number of enrolments of both sexes of Secondary general in 1997 and the Number of enrolments of both sexes of Secondary vocational in 2002?
Offer a very short reply. 6.18e+05. What is the difference between the Number of enrolments of both sexes in Primary in 1997 and the Number of enrolments of both sexes in Secondary in 2003?
Your response must be concise. 1.24e+05. What is the difference between the Number of enrolments of both sexes in Primary in 1997 and the Number of enrolments of both sexes in Secondary general in 2003?
Provide a succinct answer. 5.21e+05. What is the difference between the Number of enrolments of both sexes of Primary in 1997 and the Number of enrolments of both sexes of Secondary vocational in 2003?
Ensure brevity in your answer.  1.37e+06. What is the difference between the Number of enrolments of both sexes in Secondary in 1997 and the Number of enrolments of both sexes in Secondary general in 2003?
Your answer should be compact. 1.59e+05. What is the difference between the Number of enrolments of both sexes of Secondary in 1997 and the Number of enrolments of both sexes of Secondary vocational in 2003?
Make the answer very short. 1.00e+06. What is the difference between the Number of enrolments of both sexes of Secondary general in 1997 and the Number of enrolments of both sexes of Secondary vocational in 2003?
Provide a short and direct response. 6.26e+05. What is the difference between the Number of enrolments of both sexes in Primary in 1997 and the Number of enrolments of both sexes in Secondary in 2004?
Your response must be concise. 1.20e+05. What is the difference between the Number of enrolments of both sexes in Primary in 1997 and the Number of enrolments of both sexes in Secondary general in 2004?
Your answer should be very brief. 5.15e+05. What is the difference between the Number of enrolments of both sexes of Primary in 1997 and the Number of enrolments of both sexes of Secondary vocational in 2004?
Your response must be concise. 1.37e+06. What is the difference between the Number of enrolments of both sexes of Secondary in 1997 and the Number of enrolments of both sexes of Secondary general in 2004?
Provide a succinct answer. 1.53e+05. What is the difference between the Number of enrolments of both sexes of Secondary in 1997 and the Number of enrolments of both sexes of Secondary vocational in 2004?
Give a very brief answer. 1.01e+06. What is the difference between the Number of enrolments of both sexes in Secondary general in 1997 and the Number of enrolments of both sexes in Secondary vocational in 2004?
Ensure brevity in your answer.  6.29e+05. What is the difference between the Number of enrolments of both sexes of Primary in 1997 and the Number of enrolments of both sexes of Secondary in 2005?
Offer a terse response. 1.42e+05. What is the difference between the Number of enrolments of both sexes of Primary in 1997 and the Number of enrolments of both sexes of Secondary general in 2005?
Offer a terse response. 5.31e+05. What is the difference between the Number of enrolments of both sexes of Primary in 1997 and the Number of enrolments of both sexes of Secondary vocational in 2005?
Make the answer very short. 1.36e+06. What is the difference between the Number of enrolments of both sexes of Secondary in 1997 and the Number of enrolments of both sexes of Secondary general in 2005?
Make the answer very short. 1.69e+05. What is the difference between the Number of enrolments of both sexes of Secondary in 1997 and the Number of enrolments of both sexes of Secondary vocational in 2005?
Offer a very short reply. 9.94e+05. What is the difference between the Number of enrolments of both sexes of Secondary general in 1997 and the Number of enrolments of both sexes of Secondary vocational in 2005?
Provide a short and direct response. 6.16e+05. What is the difference between the Number of enrolments of both sexes of Primary in 1997 and the Number of enrolments of both sexes of Secondary in 2006?
Offer a very short reply. 1.65e+05. What is the difference between the Number of enrolments of both sexes in Primary in 1997 and the Number of enrolments of both sexes in Secondary general in 2006?
Your answer should be compact. 5.44e+05. What is the difference between the Number of enrolments of both sexes in Primary in 1997 and the Number of enrolments of both sexes in Secondary vocational in 2006?
Ensure brevity in your answer.  1.36e+06. What is the difference between the Number of enrolments of both sexes of Secondary in 1997 and the Number of enrolments of both sexes of Secondary general in 2006?
Ensure brevity in your answer.  1.82e+05. What is the difference between the Number of enrolments of both sexes in Secondary in 1997 and the Number of enrolments of both sexes in Secondary vocational in 2006?
Provide a short and direct response. 9.96e+05. What is the difference between the Number of enrolments of both sexes in Secondary general in 1997 and the Number of enrolments of both sexes in Secondary vocational in 2006?
Your answer should be compact. 6.18e+05. What is the difference between the Number of enrolments of both sexes of Primary in 1999 and the Number of enrolments of both sexes of Secondary in 2000?
Your response must be concise. 2.47e+05. What is the difference between the Number of enrolments of both sexes in Primary in 1999 and the Number of enrolments of both sexes in Secondary general in 2000?
Ensure brevity in your answer.  6.34e+05. What is the difference between the Number of enrolments of both sexes in Primary in 1999 and the Number of enrolments of both sexes in Secondary vocational in 2000?
Keep it short and to the point. 1.43e+06. What is the difference between the Number of enrolments of both sexes of Secondary in 1999 and the Number of enrolments of both sexes of Secondary general in 2000?
Make the answer very short. 3.27e+05. What is the difference between the Number of enrolments of both sexes in Secondary in 1999 and the Number of enrolments of both sexes in Secondary vocational in 2000?
Ensure brevity in your answer.  1.12e+06. What is the difference between the Number of enrolments of both sexes of Secondary general in 1999 and the Number of enrolments of both sexes of Secondary vocational in 2000?
Your answer should be very brief. 7.23e+05. What is the difference between the Number of enrolments of both sexes in Primary in 1999 and the Number of enrolments of both sexes in Secondary in 2002?
Provide a succinct answer. 2.10e+05. What is the difference between the Number of enrolments of both sexes in Primary in 1999 and the Number of enrolments of both sexes in Secondary general in 2002?
Your answer should be compact. 5.94e+05. What is the difference between the Number of enrolments of both sexes in Primary in 1999 and the Number of enrolments of both sexes in Secondary vocational in 2002?
Keep it short and to the point. 1.41e+06. What is the difference between the Number of enrolments of both sexes of Secondary in 1999 and the Number of enrolments of both sexes of Secondary general in 2002?
Keep it short and to the point. 2.86e+05. What is the difference between the Number of enrolments of both sexes in Secondary in 1999 and the Number of enrolments of both sexes in Secondary vocational in 2002?
Give a very brief answer. 1.10e+06. What is the difference between the Number of enrolments of both sexes in Secondary general in 1999 and the Number of enrolments of both sexes in Secondary vocational in 2002?
Keep it short and to the point. 7.06e+05. What is the difference between the Number of enrolments of both sexes in Primary in 1999 and the Number of enrolments of both sexes in Secondary in 2003?
Your answer should be compact. 1.75e+05. What is the difference between the Number of enrolments of both sexes in Primary in 1999 and the Number of enrolments of both sexes in Secondary general in 2003?
Your answer should be compact. 5.72e+05. What is the difference between the Number of enrolments of both sexes of Primary in 1999 and the Number of enrolments of both sexes of Secondary vocational in 2003?
Offer a very short reply. 1.42e+06. What is the difference between the Number of enrolments of both sexes of Secondary in 1999 and the Number of enrolments of both sexes of Secondary general in 2003?
Make the answer very short. 2.65e+05. What is the difference between the Number of enrolments of both sexes in Secondary in 1999 and the Number of enrolments of both sexes in Secondary vocational in 2003?
Offer a terse response. 1.11e+06. What is the difference between the Number of enrolments of both sexes of Secondary general in 1999 and the Number of enrolments of both sexes of Secondary vocational in 2003?
Make the answer very short. 7.15e+05. What is the difference between the Number of enrolments of both sexes in Primary in 1999 and the Number of enrolments of both sexes in Secondary in 2004?
Your answer should be compact. 1.71e+05. What is the difference between the Number of enrolments of both sexes in Primary in 1999 and the Number of enrolments of both sexes in Secondary general in 2004?
Make the answer very short. 5.66e+05. What is the difference between the Number of enrolments of both sexes of Primary in 1999 and the Number of enrolments of both sexes of Secondary vocational in 2004?
Give a very brief answer. 1.42e+06. What is the difference between the Number of enrolments of both sexes in Secondary in 1999 and the Number of enrolments of both sexes in Secondary general in 2004?
Your response must be concise. 2.58e+05. What is the difference between the Number of enrolments of both sexes of Secondary in 1999 and the Number of enrolments of both sexes of Secondary vocational in 2004?
Keep it short and to the point. 1.11e+06. What is the difference between the Number of enrolments of both sexes in Secondary general in 1999 and the Number of enrolments of both sexes in Secondary vocational in 2004?
Provide a short and direct response. 7.17e+05. What is the difference between the Number of enrolments of both sexes of Primary in 1999 and the Number of enrolments of both sexes of Secondary in 2005?
Your response must be concise. 1.93e+05. What is the difference between the Number of enrolments of both sexes of Primary in 1999 and the Number of enrolments of both sexes of Secondary general in 2005?
Your answer should be very brief. 5.82e+05. What is the difference between the Number of enrolments of both sexes in Primary in 1999 and the Number of enrolments of both sexes in Secondary vocational in 2005?
Make the answer very short. 1.41e+06. What is the difference between the Number of enrolments of both sexes of Secondary in 1999 and the Number of enrolments of both sexes of Secondary general in 2005?
Your answer should be very brief. 2.74e+05. What is the difference between the Number of enrolments of both sexes of Secondary in 1999 and the Number of enrolments of both sexes of Secondary vocational in 2005?
Offer a terse response. 1.10e+06. What is the difference between the Number of enrolments of both sexes of Secondary general in 1999 and the Number of enrolments of both sexes of Secondary vocational in 2005?
Offer a very short reply. 7.04e+05. What is the difference between the Number of enrolments of both sexes in Primary in 1999 and the Number of enrolments of both sexes in Secondary in 2006?
Provide a short and direct response. 2.16e+05. What is the difference between the Number of enrolments of both sexes of Primary in 1999 and the Number of enrolments of both sexes of Secondary general in 2006?
Your answer should be very brief. 5.95e+05. What is the difference between the Number of enrolments of both sexes in Primary in 1999 and the Number of enrolments of both sexes in Secondary vocational in 2006?
Offer a terse response. 1.41e+06. What is the difference between the Number of enrolments of both sexes in Secondary in 1999 and the Number of enrolments of both sexes in Secondary general in 2006?
Make the answer very short. 2.87e+05. What is the difference between the Number of enrolments of both sexes of Secondary in 1999 and the Number of enrolments of both sexes of Secondary vocational in 2006?
Ensure brevity in your answer.  1.10e+06. What is the difference between the Number of enrolments of both sexes of Secondary general in 1999 and the Number of enrolments of both sexes of Secondary vocational in 2006?
Your response must be concise. 7.06e+05. What is the difference between the Number of enrolments of both sexes in Primary in 2000 and the Number of enrolments of both sexes in Secondary in 2002?
Ensure brevity in your answer.  2.04e+05. What is the difference between the Number of enrolments of both sexes in Primary in 2000 and the Number of enrolments of both sexes in Secondary general in 2002?
Your response must be concise. 5.88e+05. What is the difference between the Number of enrolments of both sexes of Primary in 2000 and the Number of enrolments of both sexes of Secondary vocational in 2002?
Your answer should be compact. 1.40e+06. What is the difference between the Number of enrolments of both sexes in Secondary in 2000 and the Number of enrolments of both sexes in Secondary general in 2002?
Your response must be concise. 3.47e+05. What is the difference between the Number of enrolments of both sexes in Secondary in 2000 and the Number of enrolments of both sexes in Secondary vocational in 2002?
Provide a short and direct response. 1.16e+06. What is the difference between the Number of enrolments of both sexes of Secondary general in 2000 and the Number of enrolments of both sexes of Secondary vocational in 2002?
Offer a terse response. 7.75e+05. What is the difference between the Number of enrolments of both sexes of Primary in 2000 and the Number of enrolments of both sexes of Secondary in 2003?
Offer a very short reply. 1.68e+05. What is the difference between the Number of enrolments of both sexes in Primary in 2000 and the Number of enrolments of both sexes in Secondary general in 2003?
Offer a terse response. 5.66e+05. What is the difference between the Number of enrolments of both sexes of Primary in 2000 and the Number of enrolments of both sexes of Secondary vocational in 2003?
Provide a succinct answer. 1.41e+06. What is the difference between the Number of enrolments of both sexes of Secondary in 2000 and the Number of enrolments of both sexes of Secondary general in 2003?
Keep it short and to the point. 3.25e+05. What is the difference between the Number of enrolments of both sexes of Secondary in 2000 and the Number of enrolments of both sexes of Secondary vocational in 2003?
Give a very brief answer. 1.17e+06. What is the difference between the Number of enrolments of both sexes of Secondary general in 2000 and the Number of enrolments of both sexes of Secondary vocational in 2003?
Provide a succinct answer. 7.83e+05. What is the difference between the Number of enrolments of both sexes of Primary in 2000 and the Number of enrolments of both sexes of Secondary in 2004?
Your answer should be very brief. 1.65e+05. What is the difference between the Number of enrolments of both sexes of Primary in 2000 and the Number of enrolments of both sexes of Secondary general in 2004?
Provide a succinct answer. 5.60e+05. What is the difference between the Number of enrolments of both sexes of Primary in 2000 and the Number of enrolments of both sexes of Secondary vocational in 2004?
Your answer should be very brief. 1.41e+06. What is the difference between the Number of enrolments of both sexes of Secondary in 2000 and the Number of enrolments of both sexes of Secondary general in 2004?
Provide a succinct answer. 3.19e+05. What is the difference between the Number of enrolments of both sexes in Secondary in 2000 and the Number of enrolments of both sexes in Secondary vocational in 2004?
Offer a very short reply. 1.17e+06. What is the difference between the Number of enrolments of both sexes of Secondary general in 2000 and the Number of enrolments of both sexes of Secondary vocational in 2004?
Your answer should be very brief. 7.86e+05. What is the difference between the Number of enrolments of both sexes of Primary in 2000 and the Number of enrolments of both sexes of Secondary in 2005?
Make the answer very short. 1.87e+05. What is the difference between the Number of enrolments of both sexes of Primary in 2000 and the Number of enrolments of both sexes of Secondary general in 2005?
Ensure brevity in your answer.  5.76e+05. What is the difference between the Number of enrolments of both sexes of Primary in 2000 and the Number of enrolments of both sexes of Secondary vocational in 2005?
Offer a terse response. 1.40e+06. What is the difference between the Number of enrolments of both sexes in Secondary in 2000 and the Number of enrolments of both sexes in Secondary general in 2005?
Your response must be concise. 3.34e+05. What is the difference between the Number of enrolments of both sexes of Secondary in 2000 and the Number of enrolments of both sexes of Secondary vocational in 2005?
Your answer should be very brief. 1.16e+06. What is the difference between the Number of enrolments of both sexes of Secondary general in 2000 and the Number of enrolments of both sexes of Secondary vocational in 2005?
Offer a very short reply. 7.73e+05. What is the difference between the Number of enrolments of both sexes in Primary in 2000 and the Number of enrolments of both sexes in Secondary in 2006?
Offer a terse response. 2.10e+05. What is the difference between the Number of enrolments of both sexes in Primary in 2000 and the Number of enrolments of both sexes in Secondary general in 2006?
Provide a short and direct response. 5.89e+05. What is the difference between the Number of enrolments of both sexes in Primary in 2000 and the Number of enrolments of both sexes in Secondary vocational in 2006?
Keep it short and to the point. 1.40e+06. What is the difference between the Number of enrolments of both sexes of Secondary in 2000 and the Number of enrolments of both sexes of Secondary general in 2006?
Offer a very short reply. 3.47e+05. What is the difference between the Number of enrolments of both sexes in Secondary in 2000 and the Number of enrolments of both sexes in Secondary vocational in 2006?
Offer a terse response. 1.16e+06. What is the difference between the Number of enrolments of both sexes in Secondary general in 2000 and the Number of enrolments of both sexes in Secondary vocational in 2006?
Ensure brevity in your answer.  7.75e+05. What is the difference between the Number of enrolments of both sexes of Primary in 2002 and the Number of enrolments of both sexes of Secondary in 2003?
Make the answer very short. 1.24e+05. What is the difference between the Number of enrolments of both sexes in Primary in 2002 and the Number of enrolments of both sexes in Secondary general in 2003?
Provide a succinct answer. 5.22e+05. What is the difference between the Number of enrolments of both sexes in Primary in 2002 and the Number of enrolments of both sexes in Secondary vocational in 2003?
Provide a succinct answer. 1.37e+06. What is the difference between the Number of enrolments of both sexes of Secondary in 2002 and the Number of enrolments of both sexes of Secondary general in 2003?
Give a very brief answer. 3.63e+05. What is the difference between the Number of enrolments of both sexes in Secondary in 2002 and the Number of enrolments of both sexes in Secondary vocational in 2003?
Make the answer very short. 1.21e+06. What is the difference between the Number of enrolments of both sexes of Secondary general in 2002 and the Number of enrolments of both sexes of Secondary vocational in 2003?
Your answer should be very brief. 8.24e+05. What is the difference between the Number of enrolments of both sexes of Primary in 2002 and the Number of enrolments of both sexes of Secondary in 2004?
Ensure brevity in your answer.  1.20e+05. What is the difference between the Number of enrolments of both sexes of Primary in 2002 and the Number of enrolments of both sexes of Secondary general in 2004?
Your answer should be compact. 5.16e+05. What is the difference between the Number of enrolments of both sexes in Primary in 2002 and the Number of enrolments of both sexes in Secondary vocational in 2004?
Offer a very short reply. 1.37e+06. What is the difference between the Number of enrolments of both sexes of Secondary in 2002 and the Number of enrolments of both sexes of Secondary general in 2004?
Ensure brevity in your answer.  3.57e+05. What is the difference between the Number of enrolments of both sexes in Secondary in 2002 and the Number of enrolments of both sexes in Secondary vocational in 2004?
Offer a very short reply. 1.21e+06. What is the difference between the Number of enrolments of both sexes of Secondary general in 2002 and the Number of enrolments of both sexes of Secondary vocational in 2004?
Give a very brief answer. 8.26e+05. What is the difference between the Number of enrolments of both sexes in Primary in 2002 and the Number of enrolments of both sexes in Secondary in 2005?
Provide a succinct answer. 1.42e+05. What is the difference between the Number of enrolments of both sexes in Primary in 2002 and the Number of enrolments of both sexes in Secondary general in 2005?
Offer a terse response. 5.31e+05. What is the difference between the Number of enrolments of both sexes of Primary in 2002 and the Number of enrolments of both sexes of Secondary vocational in 2005?
Your answer should be very brief. 1.36e+06. What is the difference between the Number of enrolments of both sexes in Secondary in 2002 and the Number of enrolments of both sexes in Secondary general in 2005?
Make the answer very short. 3.72e+05. What is the difference between the Number of enrolments of both sexes in Secondary in 2002 and the Number of enrolments of both sexes in Secondary vocational in 2005?
Provide a short and direct response. 1.20e+06. What is the difference between the Number of enrolments of both sexes in Secondary general in 2002 and the Number of enrolments of both sexes in Secondary vocational in 2005?
Make the answer very short. 8.13e+05. What is the difference between the Number of enrolments of both sexes in Primary in 2002 and the Number of enrolments of both sexes in Secondary in 2006?
Ensure brevity in your answer.  1.65e+05. What is the difference between the Number of enrolments of both sexes in Primary in 2002 and the Number of enrolments of both sexes in Secondary general in 2006?
Make the answer very short. 5.44e+05. What is the difference between the Number of enrolments of both sexes in Primary in 2002 and the Number of enrolments of both sexes in Secondary vocational in 2006?
Ensure brevity in your answer.  1.36e+06. What is the difference between the Number of enrolments of both sexes of Secondary in 2002 and the Number of enrolments of both sexes of Secondary general in 2006?
Your answer should be compact. 3.85e+05. What is the difference between the Number of enrolments of both sexes in Secondary in 2002 and the Number of enrolments of both sexes in Secondary vocational in 2006?
Make the answer very short. 1.20e+06. What is the difference between the Number of enrolments of both sexes in Secondary general in 2002 and the Number of enrolments of both sexes in Secondary vocational in 2006?
Ensure brevity in your answer.  8.15e+05. What is the difference between the Number of enrolments of both sexes in Primary in 2003 and the Number of enrolments of both sexes in Secondary in 2004?
Offer a very short reply. 7.97e+04. What is the difference between the Number of enrolments of both sexes of Primary in 2003 and the Number of enrolments of both sexes of Secondary general in 2004?
Offer a very short reply. 4.75e+05. What is the difference between the Number of enrolments of both sexes of Primary in 2003 and the Number of enrolments of both sexes of Secondary vocational in 2004?
Give a very brief answer. 1.33e+06. What is the difference between the Number of enrolments of both sexes in Secondary in 2003 and the Number of enrolments of both sexes in Secondary general in 2004?
Keep it short and to the point. 3.92e+05. What is the difference between the Number of enrolments of both sexes in Secondary in 2003 and the Number of enrolments of both sexes in Secondary vocational in 2004?
Provide a short and direct response. 1.25e+06. What is the difference between the Number of enrolments of both sexes in Secondary general in 2003 and the Number of enrolments of both sexes in Secondary vocational in 2004?
Offer a terse response. 8.48e+05. What is the difference between the Number of enrolments of both sexes in Primary in 2003 and the Number of enrolments of both sexes in Secondary in 2005?
Provide a short and direct response. 1.02e+05. What is the difference between the Number of enrolments of both sexes of Primary in 2003 and the Number of enrolments of both sexes of Secondary general in 2005?
Your answer should be compact. 4.91e+05. What is the difference between the Number of enrolments of both sexes in Primary in 2003 and the Number of enrolments of both sexes in Secondary vocational in 2005?
Your answer should be very brief. 1.32e+06. What is the difference between the Number of enrolments of both sexes in Secondary in 2003 and the Number of enrolments of both sexes in Secondary general in 2005?
Your response must be concise. 4.07e+05. What is the difference between the Number of enrolments of both sexes in Secondary in 2003 and the Number of enrolments of both sexes in Secondary vocational in 2005?
Provide a short and direct response. 1.23e+06. What is the difference between the Number of enrolments of both sexes in Secondary general in 2003 and the Number of enrolments of both sexes in Secondary vocational in 2005?
Your answer should be compact. 8.35e+05. What is the difference between the Number of enrolments of both sexes in Primary in 2003 and the Number of enrolments of both sexes in Secondary in 2006?
Offer a very short reply. 1.25e+05. What is the difference between the Number of enrolments of both sexes of Primary in 2003 and the Number of enrolments of both sexes of Secondary general in 2006?
Provide a succinct answer. 5.04e+05. What is the difference between the Number of enrolments of both sexes of Primary in 2003 and the Number of enrolments of both sexes of Secondary vocational in 2006?
Your response must be concise. 1.32e+06. What is the difference between the Number of enrolments of both sexes in Secondary in 2003 and the Number of enrolments of both sexes in Secondary general in 2006?
Ensure brevity in your answer.  4.20e+05. What is the difference between the Number of enrolments of both sexes in Secondary in 2003 and the Number of enrolments of both sexes in Secondary vocational in 2006?
Offer a terse response. 1.23e+06. What is the difference between the Number of enrolments of both sexes of Secondary general in 2003 and the Number of enrolments of both sexes of Secondary vocational in 2006?
Offer a very short reply. 8.37e+05. What is the difference between the Number of enrolments of both sexes of Primary in 2004 and the Number of enrolments of both sexes of Secondary in 2005?
Your response must be concise. 1.44e+05. What is the difference between the Number of enrolments of both sexes in Primary in 2004 and the Number of enrolments of both sexes in Secondary general in 2005?
Ensure brevity in your answer.  5.33e+05. What is the difference between the Number of enrolments of both sexes in Primary in 2004 and the Number of enrolments of both sexes in Secondary vocational in 2005?
Ensure brevity in your answer.  1.36e+06. What is the difference between the Number of enrolments of both sexes in Secondary in 2004 and the Number of enrolments of both sexes in Secondary general in 2005?
Make the answer very short. 4.11e+05. What is the difference between the Number of enrolments of both sexes in Secondary in 2004 and the Number of enrolments of both sexes in Secondary vocational in 2005?
Offer a terse response. 1.24e+06. What is the difference between the Number of enrolments of both sexes of Secondary general in 2004 and the Number of enrolments of both sexes of Secondary vocational in 2005?
Offer a very short reply. 8.41e+05. What is the difference between the Number of enrolments of both sexes in Primary in 2004 and the Number of enrolments of both sexes in Secondary in 2006?
Your response must be concise. 1.67e+05. What is the difference between the Number of enrolments of both sexes of Primary in 2004 and the Number of enrolments of both sexes of Secondary general in 2006?
Keep it short and to the point. 5.46e+05. What is the difference between the Number of enrolments of both sexes in Primary in 2004 and the Number of enrolments of both sexes in Secondary vocational in 2006?
Your answer should be very brief. 1.36e+06. What is the difference between the Number of enrolments of both sexes in Secondary in 2004 and the Number of enrolments of both sexes in Secondary general in 2006?
Make the answer very short. 4.24e+05. What is the difference between the Number of enrolments of both sexes in Secondary in 2004 and the Number of enrolments of both sexes in Secondary vocational in 2006?
Provide a short and direct response. 1.24e+06. What is the difference between the Number of enrolments of both sexes of Secondary general in 2004 and the Number of enrolments of both sexes of Secondary vocational in 2006?
Your answer should be compact. 8.43e+05. What is the difference between the Number of enrolments of both sexes in Primary in 2005 and the Number of enrolments of both sexes in Secondary in 2006?
Provide a succinct answer. 1.32e+05. What is the difference between the Number of enrolments of both sexes in Primary in 2005 and the Number of enrolments of both sexes in Secondary general in 2006?
Make the answer very short. 5.11e+05. What is the difference between the Number of enrolments of both sexes of Primary in 2005 and the Number of enrolments of both sexes of Secondary vocational in 2006?
Provide a short and direct response. 1.33e+06. What is the difference between the Number of enrolments of both sexes of Secondary in 2005 and the Number of enrolments of both sexes of Secondary general in 2006?
Give a very brief answer. 4.02e+05. What is the difference between the Number of enrolments of both sexes in Secondary in 2005 and the Number of enrolments of both sexes in Secondary vocational in 2006?
Offer a very short reply. 1.22e+06. What is the difference between the Number of enrolments of both sexes in Secondary general in 2005 and the Number of enrolments of both sexes in Secondary vocational in 2006?
Make the answer very short. 8.27e+05. What is the average Number of enrolments of both sexes of Primary per year?
Your response must be concise. 1.74e+06. What is the average Number of enrolments of both sexes in Secondary per year?
Provide a succinct answer. 1.53e+06. What is the average Number of enrolments of both sexes in Secondary general per year?
Your response must be concise. 1.15e+06. What is the average Number of enrolments of both sexes of Secondary vocational per year?
Ensure brevity in your answer.  3.61e+05. In the year 1996, what is the difference between the Number of enrolments of both sexes in Primary and Number of enrolments of both sexes in Secondary?
Give a very brief answer. 3.83e+05. In the year 1996, what is the difference between the Number of enrolments of both sexes in Primary and Number of enrolments of both sexes in Secondary general?
Your answer should be very brief. 7.53e+05. In the year 1996, what is the difference between the Number of enrolments of both sexes of Primary and Number of enrolments of both sexes of Secondary vocational?
Make the answer very short. 1.43e+06. In the year 1996, what is the difference between the Number of enrolments of both sexes in Secondary and Number of enrolments of both sexes in Secondary general?
Provide a short and direct response. 3.70e+05. In the year 1996, what is the difference between the Number of enrolments of both sexes in Secondary and Number of enrolments of both sexes in Secondary vocational?
Make the answer very short. 1.04e+06. In the year 1996, what is the difference between the Number of enrolments of both sexes in Secondary general and Number of enrolments of both sexes in Secondary vocational?
Provide a short and direct response. 6.73e+05. In the year 1997, what is the difference between the Number of enrolments of both sexes in Primary and Number of enrolments of both sexes in Secondary?
Provide a short and direct response. 3.63e+05. In the year 1997, what is the difference between the Number of enrolments of both sexes of Primary and Number of enrolments of both sexes of Secondary general?
Provide a succinct answer. 7.41e+05. In the year 1997, what is the difference between the Number of enrolments of both sexes in Primary and Number of enrolments of both sexes in Secondary vocational?
Your answer should be compact. 1.48e+06. In the year 1997, what is the difference between the Number of enrolments of both sexes in Secondary and Number of enrolments of both sexes in Secondary general?
Offer a very short reply. 3.78e+05. In the year 1997, what is the difference between the Number of enrolments of both sexes in Secondary and Number of enrolments of both sexes in Secondary vocational?
Your answer should be very brief. 1.11e+06. In the year 1997, what is the difference between the Number of enrolments of both sexes of Secondary general and Number of enrolments of both sexes of Secondary vocational?
Your answer should be compact. 7.36e+05. In the year 1999, what is the difference between the Number of enrolments of both sexes of Primary and Number of enrolments of both sexes of Secondary?
Provide a short and direct response. 3.08e+05. In the year 1999, what is the difference between the Number of enrolments of both sexes of Primary and Number of enrolments of both sexes of Secondary general?
Your answer should be compact. 7.03e+05. In the year 1999, what is the difference between the Number of enrolments of both sexes of Primary and Number of enrolments of both sexes of Secondary vocational?
Provide a succinct answer. 1.43e+06. In the year 1999, what is the difference between the Number of enrolments of both sexes in Secondary and Number of enrolments of both sexes in Secondary general?
Make the answer very short. 3.96e+05. In the year 1999, what is the difference between the Number of enrolments of both sexes of Secondary and Number of enrolments of both sexes of Secondary vocational?
Your response must be concise. 1.13e+06. In the year 1999, what is the difference between the Number of enrolments of both sexes in Secondary general and Number of enrolments of both sexes in Secondary vocational?
Make the answer very short. 7.31e+05. In the year 2000, what is the difference between the Number of enrolments of both sexes in Primary and Number of enrolments of both sexes in Secondary?
Offer a very short reply. 2.41e+05. In the year 2000, what is the difference between the Number of enrolments of both sexes of Primary and Number of enrolments of both sexes of Secondary general?
Ensure brevity in your answer.  6.28e+05. In the year 2000, what is the difference between the Number of enrolments of both sexes of Primary and Number of enrolments of both sexes of Secondary vocational?
Offer a terse response. 1.42e+06. In the year 2000, what is the difference between the Number of enrolments of both sexes in Secondary and Number of enrolments of both sexes in Secondary general?
Keep it short and to the point. 3.87e+05. In the year 2000, what is the difference between the Number of enrolments of both sexes of Secondary and Number of enrolments of both sexes of Secondary vocational?
Keep it short and to the point. 1.18e+06. In the year 2000, what is the difference between the Number of enrolments of both sexes in Secondary general and Number of enrolments of both sexes in Secondary vocational?
Offer a very short reply. 7.92e+05. In the year 2002, what is the difference between the Number of enrolments of both sexes of Primary and Number of enrolments of both sexes of Secondary?
Keep it short and to the point. 1.59e+05. In the year 2002, what is the difference between the Number of enrolments of both sexes in Primary and Number of enrolments of both sexes in Secondary general?
Give a very brief answer. 5.43e+05. In the year 2002, what is the difference between the Number of enrolments of both sexes of Primary and Number of enrolments of both sexes of Secondary vocational?
Keep it short and to the point. 1.36e+06. In the year 2002, what is the difference between the Number of enrolments of both sexes in Secondary and Number of enrolments of both sexes in Secondary general?
Your answer should be very brief. 3.84e+05. In the year 2002, what is the difference between the Number of enrolments of both sexes of Secondary and Number of enrolments of both sexes of Secondary vocational?
Ensure brevity in your answer.  1.20e+06. In the year 2002, what is the difference between the Number of enrolments of both sexes in Secondary general and Number of enrolments of both sexes in Secondary vocational?
Your response must be concise. 8.15e+05. In the year 2003, what is the difference between the Number of enrolments of both sexes of Primary and Number of enrolments of both sexes of Secondary?
Keep it short and to the point. 8.34e+04. In the year 2003, what is the difference between the Number of enrolments of both sexes in Primary and Number of enrolments of both sexes in Secondary general?
Ensure brevity in your answer.  4.81e+05. In the year 2003, what is the difference between the Number of enrolments of both sexes of Primary and Number of enrolments of both sexes of Secondary vocational?
Give a very brief answer. 1.33e+06. In the year 2003, what is the difference between the Number of enrolments of both sexes in Secondary and Number of enrolments of both sexes in Secondary general?
Provide a short and direct response. 3.98e+05. In the year 2003, what is the difference between the Number of enrolments of both sexes of Secondary and Number of enrolments of both sexes of Secondary vocational?
Provide a succinct answer. 1.24e+06. In the year 2003, what is the difference between the Number of enrolments of both sexes of Secondary general and Number of enrolments of both sexes of Secondary vocational?
Offer a very short reply. 8.46e+05. In the year 2004, what is the difference between the Number of enrolments of both sexes of Primary and Number of enrolments of both sexes of Secondary?
Offer a terse response. 1.22e+05. In the year 2004, what is the difference between the Number of enrolments of both sexes in Primary and Number of enrolments of both sexes in Secondary general?
Provide a short and direct response. 5.18e+05. In the year 2004, what is the difference between the Number of enrolments of both sexes of Primary and Number of enrolments of both sexes of Secondary vocational?
Provide a succinct answer. 1.37e+06. In the year 2004, what is the difference between the Number of enrolments of both sexes in Secondary and Number of enrolments of both sexes in Secondary general?
Offer a very short reply. 3.95e+05. In the year 2004, what is the difference between the Number of enrolments of both sexes of Secondary and Number of enrolments of both sexes of Secondary vocational?
Ensure brevity in your answer.  1.25e+06. In the year 2004, what is the difference between the Number of enrolments of both sexes in Secondary general and Number of enrolments of both sexes in Secondary vocational?
Give a very brief answer. 8.54e+05. In the year 2005, what is the difference between the Number of enrolments of both sexes in Primary and Number of enrolments of both sexes in Secondary?
Offer a terse response. 1.09e+05. In the year 2005, what is the difference between the Number of enrolments of both sexes in Primary and Number of enrolments of both sexes in Secondary general?
Offer a very short reply. 4.98e+05. In the year 2005, what is the difference between the Number of enrolments of both sexes of Primary and Number of enrolments of both sexes of Secondary vocational?
Provide a succinct answer. 1.32e+06. In the year 2005, what is the difference between the Number of enrolments of both sexes in Secondary and Number of enrolments of both sexes in Secondary general?
Provide a succinct answer. 3.89e+05. In the year 2005, what is the difference between the Number of enrolments of both sexes of Secondary and Number of enrolments of both sexes of Secondary vocational?
Offer a terse response. 1.21e+06. In the year 2005, what is the difference between the Number of enrolments of both sexes of Secondary general and Number of enrolments of both sexes of Secondary vocational?
Provide a succinct answer. 8.25e+05. In the year 2006, what is the difference between the Number of enrolments of both sexes in Primary and Number of enrolments of both sexes in Secondary?
Provide a succinct answer. 1.06e+05. In the year 2006, what is the difference between the Number of enrolments of both sexes of Primary and Number of enrolments of both sexes of Secondary general?
Ensure brevity in your answer.  4.85e+05. In the year 2006, what is the difference between the Number of enrolments of both sexes of Primary and Number of enrolments of both sexes of Secondary vocational?
Provide a succinct answer. 1.30e+06. In the year 2006, what is the difference between the Number of enrolments of both sexes in Secondary and Number of enrolments of both sexes in Secondary general?
Make the answer very short. 3.79e+05. In the year 2006, what is the difference between the Number of enrolments of both sexes of Secondary and Number of enrolments of both sexes of Secondary vocational?
Provide a succinct answer. 1.19e+06. In the year 2006, what is the difference between the Number of enrolments of both sexes of Secondary general and Number of enrolments of both sexes of Secondary vocational?
Ensure brevity in your answer.  8.14e+05. What is the ratio of the Number of enrolments of both sexes in Primary in 1996 to that in 1997?
Your response must be concise. 0.96. What is the ratio of the Number of enrolments of both sexes of Secondary in 1996 to that in 1997?
Your answer should be very brief. 0.94. What is the ratio of the Number of enrolments of both sexes of Secondary general in 1996 to that in 1997?
Provide a short and direct response. 0.92. What is the ratio of the Number of enrolments of both sexes in Secondary vocational in 1996 to that in 1997?
Your answer should be very brief. 0.94. What is the ratio of the Number of enrolments of both sexes of Primary in 1996 to that in 1999?
Keep it short and to the point. 0.94. What is the ratio of the Number of enrolments of both sexes in Secondary in 1996 to that in 1999?
Your answer should be very brief. 0.87. What is the ratio of the Number of enrolments of both sexes of Secondary general in 1996 to that in 1999?
Offer a terse response. 0.85. What is the ratio of the Number of enrolments of both sexes of Secondary vocational in 1996 to that in 1999?
Your response must be concise. 0.71. What is the ratio of the Number of enrolments of both sexes in Primary in 1996 to that in 2000?
Offer a terse response. 0.94. What is the ratio of the Number of enrolments of both sexes of Secondary in 1996 to that in 2000?
Provide a short and direct response. 0.84. What is the ratio of the Number of enrolments of both sexes in Secondary general in 1996 to that in 2000?
Give a very brief answer. 0.8. What is the ratio of the Number of enrolments of both sexes in Secondary vocational in 1996 to that in 2000?
Make the answer very short. 0.69. What is the ratio of the Number of enrolments of both sexes in Primary in 1996 to that in 2002?
Provide a short and direct response. 0.96. What is the ratio of the Number of enrolments of both sexes in Secondary in 1996 to that in 2002?
Provide a short and direct response. 0.82. What is the ratio of the Number of enrolments of both sexes of Secondary general in 1996 to that in 2002?
Keep it short and to the point. 0.77. What is the ratio of the Number of enrolments of both sexes of Secondary vocational in 1996 to that in 2002?
Provide a succinct answer. 0.66. What is the ratio of the Number of enrolments of both sexes in Primary in 1996 to that in 2003?
Your response must be concise. 0.98. What is the ratio of the Number of enrolments of both sexes of Secondary in 1996 to that in 2003?
Provide a short and direct response. 0.8. What is the ratio of the Number of enrolments of both sexes of Secondary general in 1996 to that in 2003?
Offer a very short reply. 0.76. What is the ratio of the Number of enrolments of both sexes in Secondary vocational in 1996 to that in 2003?
Keep it short and to the point. 0.68. What is the ratio of the Number of enrolments of both sexes in Primary in 1996 to that in 2004?
Ensure brevity in your answer.  0.96. What is the ratio of the Number of enrolments of both sexes of Secondary in 1996 to that in 2004?
Your answer should be compact. 0.8. What is the ratio of the Number of enrolments of both sexes of Secondary general in 1996 to that in 2004?
Your response must be concise. 0.75. What is the ratio of the Number of enrolments of both sexes of Secondary vocational in 1996 to that in 2004?
Your answer should be very brief. 0.68. What is the ratio of the Number of enrolments of both sexes of Primary in 1996 to that in 2005?
Your response must be concise. 0.98. What is the ratio of the Number of enrolments of both sexes of Secondary in 1996 to that in 2005?
Make the answer very short. 0.81. What is the ratio of the Number of enrolments of both sexes of Secondary general in 1996 to that in 2005?
Offer a terse response. 0.76. What is the ratio of the Number of enrolments of both sexes in Secondary vocational in 1996 to that in 2005?
Make the answer very short. 0.66. What is the ratio of the Number of enrolments of both sexes in Secondary in 1996 to that in 2006?
Make the answer very short. 0.82. What is the ratio of the Number of enrolments of both sexes in Secondary general in 1996 to that in 2006?
Provide a succinct answer. 0.77. What is the ratio of the Number of enrolments of both sexes in Secondary vocational in 1996 to that in 2006?
Provide a succinct answer. 0.66. What is the ratio of the Number of enrolments of both sexes of Primary in 1997 to that in 1999?
Make the answer very short. 0.97. What is the ratio of the Number of enrolments of both sexes of Secondary in 1997 to that in 1999?
Give a very brief answer. 0.93. What is the ratio of the Number of enrolments of both sexes of Secondary general in 1997 to that in 1999?
Your answer should be compact. 0.92. What is the ratio of the Number of enrolments of both sexes of Secondary vocational in 1997 to that in 1999?
Offer a terse response. 0.75. What is the ratio of the Number of enrolments of both sexes in Primary in 1997 to that in 2000?
Make the answer very short. 0.98. What is the ratio of the Number of enrolments of both sexes in Secondary in 1997 to that in 2000?
Make the answer very short. 0.89. What is the ratio of the Number of enrolments of both sexes of Secondary general in 1997 to that in 2000?
Make the answer very short. 0.87. What is the ratio of the Number of enrolments of both sexes in Secondary vocational in 1997 to that in 2000?
Provide a short and direct response. 0.73. What is the ratio of the Number of enrolments of both sexes of Secondary in 1997 to that in 2002?
Offer a terse response. 0.87. What is the ratio of the Number of enrolments of both sexes of Secondary general in 1997 to that in 2002?
Give a very brief answer. 0.84. What is the ratio of the Number of enrolments of both sexes in Secondary vocational in 1997 to that in 2002?
Offer a terse response. 0.7. What is the ratio of the Number of enrolments of both sexes of Primary in 1997 to that in 2003?
Your answer should be compact. 1.02. What is the ratio of the Number of enrolments of both sexes in Secondary in 1997 to that in 2003?
Keep it short and to the point. 0.85. What is the ratio of the Number of enrolments of both sexes of Secondary general in 1997 to that in 2003?
Provide a short and direct response. 0.82. What is the ratio of the Number of enrolments of both sexes in Secondary vocational in 1997 to that in 2003?
Your response must be concise. 0.72. What is the ratio of the Number of enrolments of both sexes of Secondary in 1997 to that in 2004?
Offer a very short reply. 0.85. What is the ratio of the Number of enrolments of both sexes in Secondary general in 1997 to that in 2004?
Provide a succinct answer. 0.82. What is the ratio of the Number of enrolments of both sexes of Secondary vocational in 1997 to that in 2004?
Offer a terse response. 0.72. What is the ratio of the Number of enrolments of both sexes in Primary in 1997 to that in 2005?
Provide a short and direct response. 1.02. What is the ratio of the Number of enrolments of both sexes of Secondary in 1997 to that in 2005?
Your answer should be compact. 0.86. What is the ratio of the Number of enrolments of both sexes in Secondary general in 1997 to that in 2005?
Make the answer very short. 0.83. What is the ratio of the Number of enrolments of both sexes of Secondary vocational in 1997 to that in 2005?
Your answer should be compact. 0.7. What is the ratio of the Number of enrolments of both sexes in Primary in 1997 to that in 2006?
Provide a succinct answer. 1.03. What is the ratio of the Number of enrolments of both sexes in Secondary in 1997 to that in 2006?
Keep it short and to the point. 0.88. What is the ratio of the Number of enrolments of both sexes of Secondary general in 1997 to that in 2006?
Provide a short and direct response. 0.84. What is the ratio of the Number of enrolments of both sexes of Secondary vocational in 1997 to that in 2006?
Give a very brief answer. 0.7. What is the ratio of the Number of enrolments of both sexes in Primary in 1999 to that in 2000?
Your answer should be very brief. 1. What is the ratio of the Number of enrolments of both sexes of Secondary in 1999 to that in 2000?
Provide a succinct answer. 0.96. What is the ratio of the Number of enrolments of both sexes of Secondary general in 1999 to that in 2000?
Give a very brief answer. 0.94. What is the ratio of the Number of enrolments of both sexes of Primary in 1999 to that in 2002?
Make the answer very short. 1.03. What is the ratio of the Number of enrolments of both sexes of Secondary in 1999 to that in 2002?
Give a very brief answer. 0.94. What is the ratio of the Number of enrolments of both sexes of Secondary general in 1999 to that in 2002?
Give a very brief answer. 0.91. What is the ratio of the Number of enrolments of both sexes in Secondary vocational in 1999 to that in 2002?
Offer a terse response. 0.94. What is the ratio of the Number of enrolments of both sexes of Primary in 1999 to that in 2003?
Your response must be concise. 1.05. What is the ratio of the Number of enrolments of both sexes in Secondary in 1999 to that in 2003?
Keep it short and to the point. 0.92. What is the ratio of the Number of enrolments of both sexes of Secondary general in 1999 to that in 2003?
Offer a very short reply. 0.89. What is the ratio of the Number of enrolments of both sexes of Secondary vocational in 1999 to that in 2003?
Make the answer very short. 0.96. What is the ratio of the Number of enrolments of both sexes in Primary in 1999 to that in 2004?
Ensure brevity in your answer.  1.03. What is the ratio of the Number of enrolments of both sexes of Secondary in 1999 to that in 2004?
Provide a short and direct response. 0.92. What is the ratio of the Number of enrolments of both sexes of Secondary general in 1999 to that in 2004?
Your response must be concise. 0.89. What is the ratio of the Number of enrolments of both sexes in Secondary vocational in 1999 to that in 2004?
Give a very brief answer. 0.96. What is the ratio of the Number of enrolments of both sexes in Primary in 1999 to that in 2005?
Your answer should be very brief. 1.05. What is the ratio of the Number of enrolments of both sexes of Secondary in 1999 to that in 2005?
Provide a short and direct response. 0.93. What is the ratio of the Number of enrolments of both sexes in Secondary general in 1999 to that in 2005?
Make the answer very short. 0.9. What is the ratio of the Number of enrolments of both sexes in Secondary vocational in 1999 to that in 2005?
Ensure brevity in your answer.  0.93. What is the ratio of the Number of enrolments of both sexes in Primary in 1999 to that in 2006?
Keep it short and to the point. 1.06. What is the ratio of the Number of enrolments of both sexes in Secondary in 1999 to that in 2006?
Your response must be concise. 0.94. What is the ratio of the Number of enrolments of both sexes of Secondary general in 1999 to that in 2006?
Your answer should be compact. 0.91. What is the ratio of the Number of enrolments of both sexes of Secondary vocational in 1999 to that in 2006?
Give a very brief answer. 0.94. What is the ratio of the Number of enrolments of both sexes in Primary in 2000 to that in 2002?
Provide a short and direct response. 1.03. What is the ratio of the Number of enrolments of both sexes of Secondary in 2000 to that in 2002?
Keep it short and to the point. 0.98. What is the ratio of the Number of enrolments of both sexes of Secondary general in 2000 to that in 2002?
Your answer should be very brief. 0.97. What is the ratio of the Number of enrolments of both sexes in Secondary vocational in 2000 to that in 2002?
Give a very brief answer. 0.96. What is the ratio of the Number of enrolments of both sexes in Primary in 2000 to that in 2003?
Your response must be concise. 1.05. What is the ratio of the Number of enrolments of both sexes of Secondary in 2000 to that in 2003?
Provide a succinct answer. 0.96. What is the ratio of the Number of enrolments of both sexes in Secondary general in 2000 to that in 2003?
Give a very brief answer. 0.95. What is the ratio of the Number of enrolments of both sexes of Secondary vocational in 2000 to that in 2003?
Your response must be concise. 0.98. What is the ratio of the Number of enrolments of both sexes of Primary in 2000 to that in 2004?
Your answer should be very brief. 1.02. What is the ratio of the Number of enrolments of both sexes in Secondary in 2000 to that in 2004?
Give a very brief answer. 0.95. What is the ratio of the Number of enrolments of both sexes of Secondary general in 2000 to that in 2004?
Your response must be concise. 0.94. What is the ratio of the Number of enrolments of both sexes of Secondary vocational in 2000 to that in 2004?
Make the answer very short. 0.98. What is the ratio of the Number of enrolments of both sexes in Primary in 2000 to that in 2005?
Ensure brevity in your answer.  1.05. What is the ratio of the Number of enrolments of both sexes of Secondary in 2000 to that in 2005?
Provide a short and direct response. 0.97. What is the ratio of the Number of enrolments of both sexes of Secondary general in 2000 to that in 2005?
Your response must be concise. 0.96. What is the ratio of the Number of enrolments of both sexes of Secondary vocational in 2000 to that in 2005?
Give a very brief answer. 0.95. What is the ratio of the Number of enrolments of both sexes of Primary in 2000 to that in 2006?
Offer a very short reply. 1.06. What is the ratio of the Number of enrolments of both sexes of Secondary general in 2000 to that in 2006?
Your response must be concise. 0.97. What is the ratio of the Number of enrolments of both sexes in Secondary vocational in 2000 to that in 2006?
Offer a terse response. 0.96. What is the ratio of the Number of enrolments of both sexes in Primary in 2002 to that in 2003?
Ensure brevity in your answer.  1.02. What is the ratio of the Number of enrolments of both sexes in Secondary in 2002 to that in 2003?
Give a very brief answer. 0.98. What is the ratio of the Number of enrolments of both sexes in Secondary general in 2002 to that in 2003?
Your response must be concise. 0.98. What is the ratio of the Number of enrolments of both sexes in Secondary vocational in 2002 to that in 2003?
Your response must be concise. 1.02. What is the ratio of the Number of enrolments of both sexes in Primary in 2002 to that in 2004?
Provide a short and direct response. 1. What is the ratio of the Number of enrolments of both sexes of Secondary in 2002 to that in 2004?
Keep it short and to the point. 0.98. What is the ratio of the Number of enrolments of both sexes in Secondary general in 2002 to that in 2004?
Ensure brevity in your answer.  0.98. What is the ratio of the Number of enrolments of both sexes of Secondary vocational in 2002 to that in 2004?
Your answer should be very brief. 1.03. What is the ratio of the Number of enrolments of both sexes in Primary in 2002 to that in 2005?
Provide a short and direct response. 1.02. What is the ratio of the Number of enrolments of both sexes of Secondary in 2002 to that in 2005?
Ensure brevity in your answer.  0.99. What is the ratio of the Number of enrolments of both sexes in Secondary vocational in 2002 to that in 2005?
Give a very brief answer. 0.99. What is the ratio of the Number of enrolments of both sexes in Primary in 2002 to that in 2006?
Provide a succinct answer. 1.03. What is the ratio of the Number of enrolments of both sexes of Secondary general in 2002 to that in 2006?
Ensure brevity in your answer.  1. What is the ratio of the Number of enrolments of both sexes in Primary in 2003 to that in 2004?
Keep it short and to the point. 0.98. What is the ratio of the Number of enrolments of both sexes in Secondary in 2003 to that in 2004?
Make the answer very short. 1. What is the ratio of the Number of enrolments of both sexes of Secondary vocational in 2003 to that in 2004?
Keep it short and to the point. 1.01. What is the ratio of the Number of enrolments of both sexes in Primary in 2003 to that in 2005?
Give a very brief answer. 1. What is the ratio of the Number of enrolments of both sexes in Secondary in 2003 to that in 2005?
Give a very brief answer. 1.01. What is the ratio of the Number of enrolments of both sexes in Secondary general in 2003 to that in 2005?
Your answer should be compact. 1.01. What is the ratio of the Number of enrolments of both sexes of Secondary vocational in 2003 to that in 2005?
Your response must be concise. 0.97. What is the ratio of the Number of enrolments of both sexes in Primary in 2003 to that in 2006?
Give a very brief answer. 1.01. What is the ratio of the Number of enrolments of both sexes in Secondary general in 2003 to that in 2006?
Offer a very short reply. 1.02. What is the ratio of the Number of enrolments of both sexes of Secondary vocational in 2003 to that in 2006?
Your answer should be compact. 0.98. What is the ratio of the Number of enrolments of both sexes in Primary in 2004 to that in 2005?
Offer a terse response. 1.02. What is the ratio of the Number of enrolments of both sexes of Secondary in 2004 to that in 2005?
Offer a very short reply. 1.01. What is the ratio of the Number of enrolments of both sexes of Secondary general in 2004 to that in 2005?
Your answer should be compact. 1.01. What is the ratio of the Number of enrolments of both sexes of Secondary vocational in 2004 to that in 2005?
Your answer should be very brief. 0.97. What is the ratio of the Number of enrolments of both sexes in Primary in 2004 to that in 2006?
Your answer should be very brief. 1.04. What is the ratio of the Number of enrolments of both sexes in Secondary in 2004 to that in 2006?
Provide a short and direct response. 1.03. What is the ratio of the Number of enrolments of both sexes of Secondary general in 2004 to that in 2006?
Offer a terse response. 1.02. What is the ratio of the Number of enrolments of both sexes of Primary in 2005 to that in 2006?
Your answer should be compact. 1.02. What is the ratio of the Number of enrolments of both sexes in Secondary in 2005 to that in 2006?
Provide a succinct answer. 1.01. What is the ratio of the Number of enrolments of both sexes in Secondary general in 2005 to that in 2006?
Your answer should be compact. 1.01. What is the ratio of the Number of enrolments of both sexes in Secondary vocational in 2005 to that in 2006?
Offer a very short reply. 1.01. What is the difference between the highest and the second highest Number of enrolments of both sexes of Primary?
Provide a succinct answer. 6097. What is the difference between the highest and the second highest Number of enrolments of both sexes of Secondary?
Offer a terse response. 3769. What is the difference between the highest and the second highest Number of enrolments of both sexes of Secondary general?
Keep it short and to the point. 6022. What is the difference between the highest and the second highest Number of enrolments of both sexes of Secondary vocational?
Your answer should be compact. 2116. What is the difference between the highest and the lowest Number of enrolments of both sexes of Primary?
Your response must be concise. 1.17e+05. What is the difference between the highest and the lowest Number of enrolments of both sexes in Secondary?
Provide a succinct answer. 3.29e+05. What is the difference between the highest and the lowest Number of enrolments of both sexes of Secondary general?
Your answer should be very brief. 3.04e+05. What is the difference between the highest and the lowest Number of enrolments of both sexes in Secondary vocational?
Offer a terse response. 1.36e+05. 